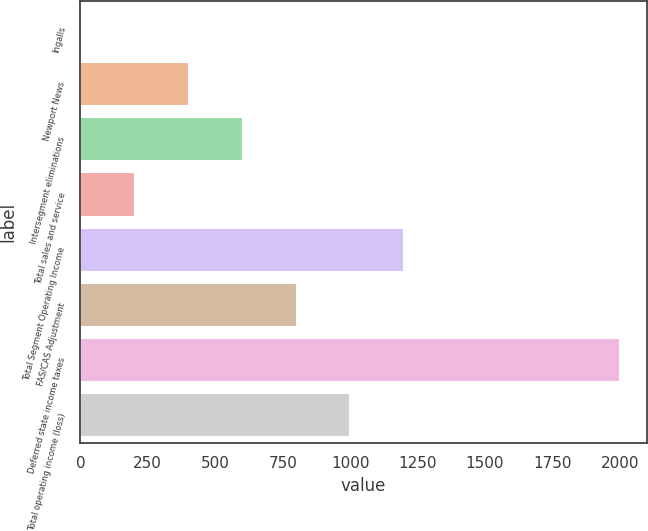Convert chart to OTSL. <chart><loc_0><loc_0><loc_500><loc_500><bar_chart><fcel>Ingalls<fcel>Newport News<fcel>Intersegment eliminations<fcel>Total sales and service<fcel>Total Segment Operating Income<fcel>FAS/CAS Adjustment<fcel>Deferred state income taxes<fcel>Total operating income (loss)<nl><fcel>2<fcel>401.6<fcel>601.4<fcel>201.8<fcel>1200.8<fcel>801.2<fcel>2000<fcel>1001<nl></chart> 